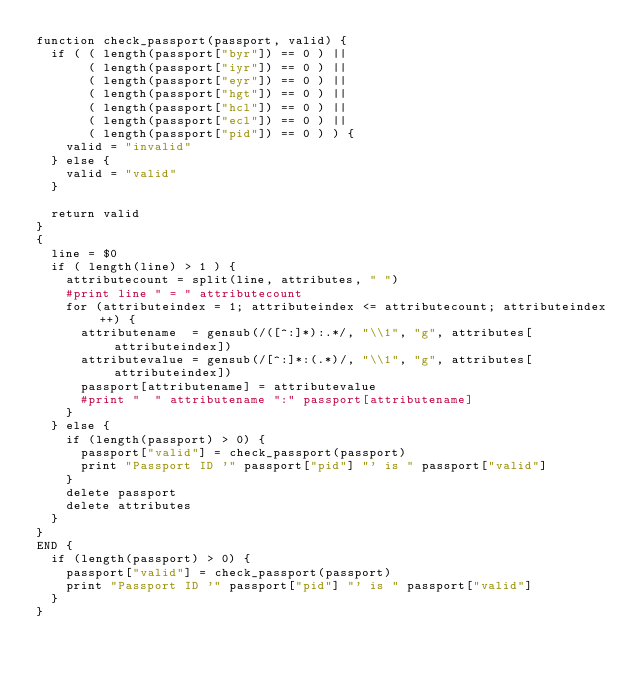<code> <loc_0><loc_0><loc_500><loc_500><_Awk_>function check_passport(passport, valid) {
  if ( ( length(passport["byr"]) == 0 ) ||
       ( length(passport["iyr"]) == 0 ) ||
       ( length(passport["eyr"]) == 0 ) ||
       ( length(passport["hgt"]) == 0 ) ||
       ( length(passport["hcl"]) == 0 ) ||
       ( length(passport["ecl"]) == 0 ) ||
       ( length(passport["pid"]) == 0 ) ) {
    valid = "invalid"
  } else {
    valid = "valid"
  }

  return valid
}
{
  line = $0
  if ( length(line) > 1 ) {
    attributecount = split(line, attributes, " ")
    #print line " = " attributecount
    for (attributeindex = 1; attributeindex <= attributecount; attributeindex++) {
      attributename  = gensub(/([^:]*):.*/, "\\1", "g", attributes[attributeindex])
      attributevalue = gensub(/[^:]*:(.*)/, "\\1", "g", attributes[attributeindex])
      passport[attributename] = attributevalue
      #print "  " attributename ":" passport[attributename]
    }
  } else {
    if (length(passport) > 0) {
      passport["valid"] = check_passport(passport)
      print "Passport ID '" passport["pid"] "' is " passport["valid"]
    }
    delete passport
    delete attributes
  }
}
END {
  if (length(passport) > 0) {
    passport["valid"] = check_passport(passport)
    print "Passport ID '" passport["pid"] "' is " passport["valid"]
  }
}
</code> 